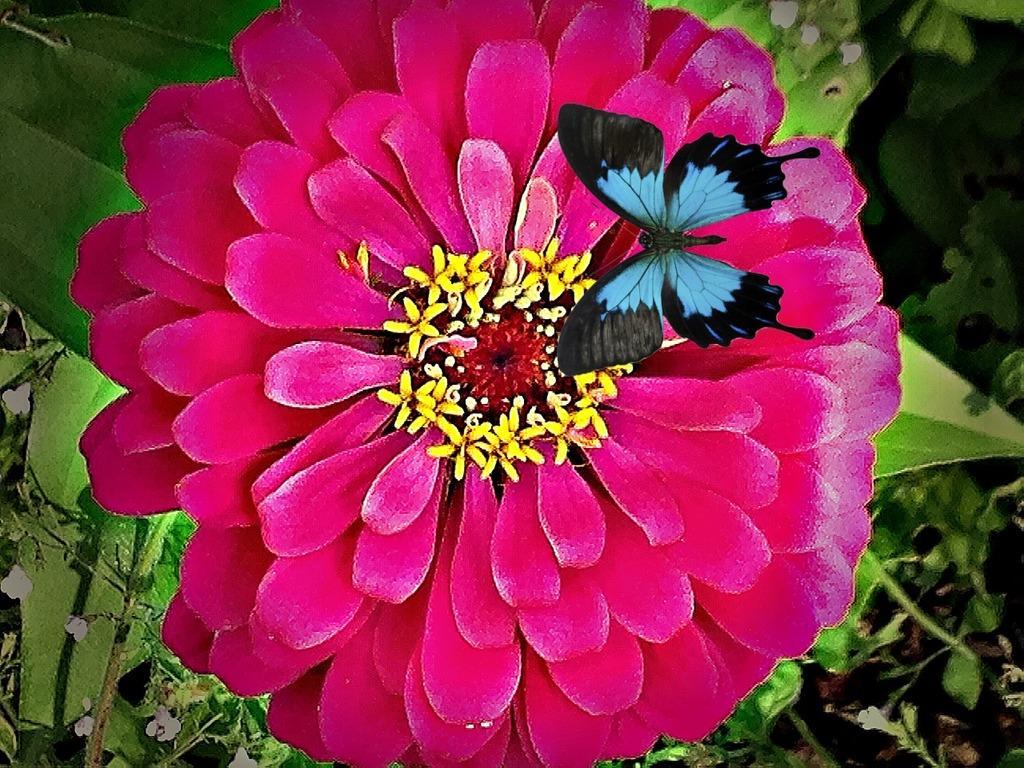In one or two sentences, can you explain what this image depicts? In this image I can see a butterfly and a red color flower. The background of the image is blurred. 